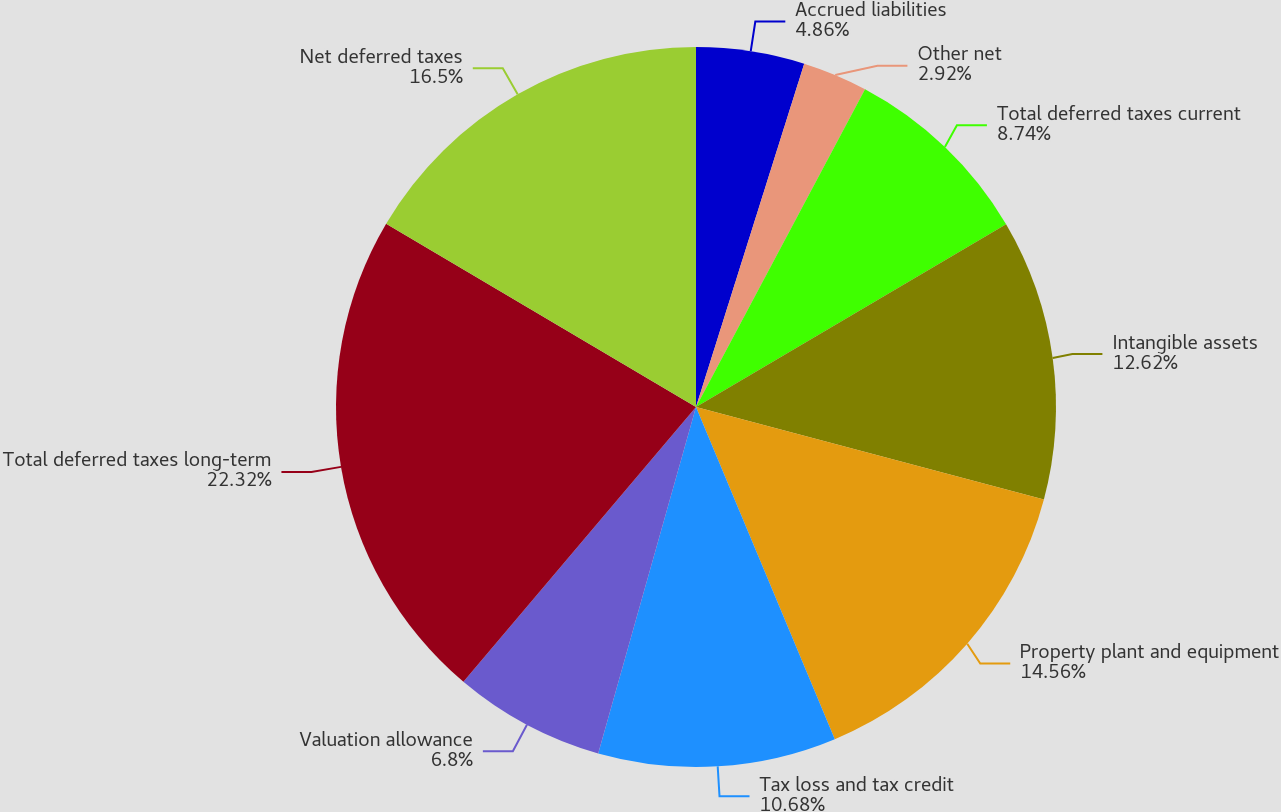Convert chart to OTSL. <chart><loc_0><loc_0><loc_500><loc_500><pie_chart><fcel>Accrued liabilities<fcel>Other net<fcel>Total deferred taxes current<fcel>Intangible assets<fcel>Property plant and equipment<fcel>Tax loss and tax credit<fcel>Valuation allowance<fcel>Total deferred taxes long-term<fcel>Net deferred taxes<nl><fcel>4.86%<fcel>2.92%<fcel>8.74%<fcel>12.62%<fcel>14.56%<fcel>10.68%<fcel>6.8%<fcel>22.32%<fcel>16.5%<nl></chart> 